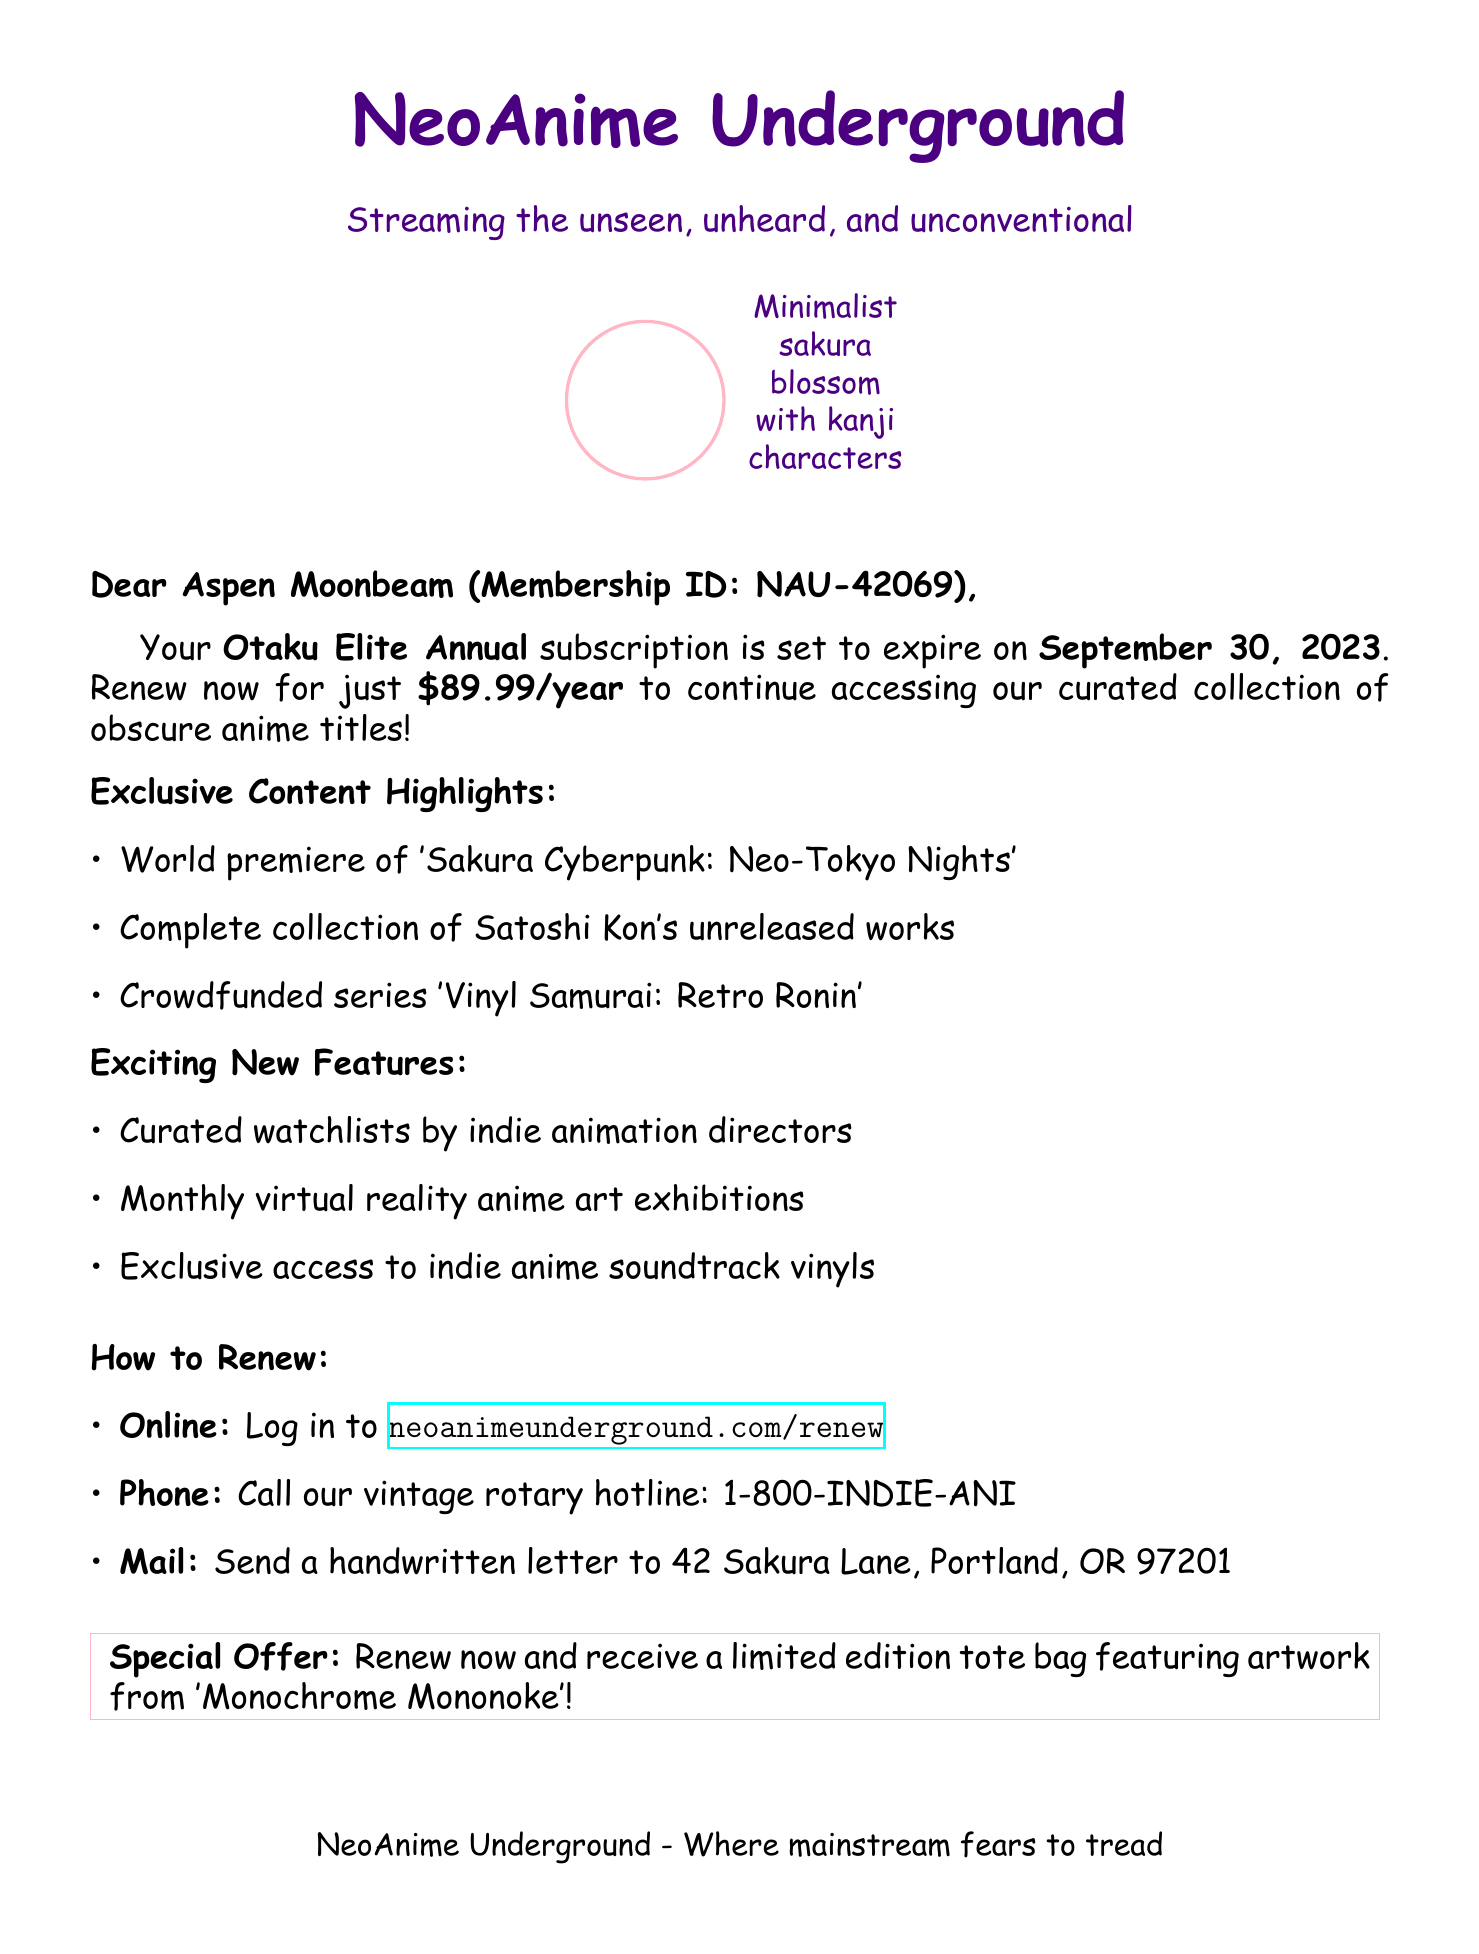What is the name of the subscription? The subscription is referred to as "Otaku Elite Annual" in the document.
Answer: Otaku Elite Annual When does the subscription expire? The document states that the subscription is set to expire on September 30, 2023.
Answer: September 30, 2023 What is the renewal price? The renewal price mentioned in the document is $89.99 per year.
Answer: $89.99/year What is a highlight of the exclusive content? One example of exclusive content is the world premiere of 'Sakura Cyberpunk: Neo-Tokyo Nights'.
Answer: 'Sakura Cyberpunk: Neo-Tokyo Nights' How can you renew your subscription online? The document provides the URL for renewing online, which is neoanimeunderground.com/renew.
Answer: neoanimeunderground.com/renew What special offer comes with renewing? The document mentions a limited edition tote bag featuring artwork from 'Monochrome Mononoke'.
Answer: limited edition tote bag What type of service is NeoAnime Underground? The document describes it as a streaming service for indie anime titles.
Answer: streaming service What is one new feature introduced? One of the exciting new features is curated watchlists by indie animation directors.
Answer: curated watchlists What is the contact method for renewing by phone? The phone contact method provided is 1-800-INDIE-ANI.
Answer: 1-800-INDIE-ANI 